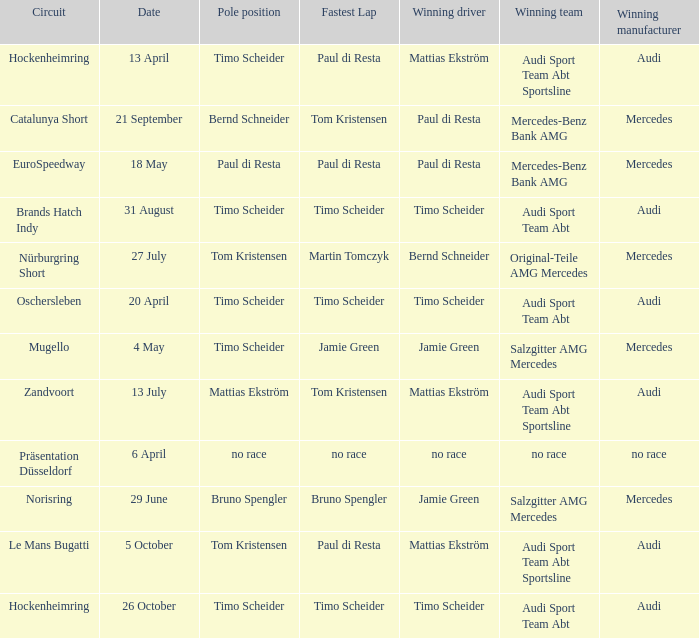What is the fastest lap in the Le Mans Bugatti circuit? Paul di Resta. I'm looking to parse the entire table for insights. Could you assist me with that? {'header': ['Circuit', 'Date', 'Pole position', 'Fastest Lap', 'Winning driver', 'Winning team', 'Winning manufacturer'], 'rows': [['Hockenheimring', '13 April', 'Timo Scheider', 'Paul di Resta', 'Mattias Ekström', 'Audi Sport Team Abt Sportsline', 'Audi'], ['Catalunya Short', '21 September', 'Bernd Schneider', 'Tom Kristensen', 'Paul di Resta', 'Mercedes-Benz Bank AMG', 'Mercedes'], ['EuroSpeedway', '18 May', 'Paul di Resta', 'Paul di Resta', 'Paul di Resta', 'Mercedes-Benz Bank AMG', 'Mercedes'], ['Brands Hatch Indy', '31 August', 'Timo Scheider', 'Timo Scheider', 'Timo Scheider', 'Audi Sport Team Abt', 'Audi'], ['Nürburgring Short', '27 July', 'Tom Kristensen', 'Martin Tomczyk', 'Bernd Schneider', 'Original-Teile AMG Mercedes', 'Mercedes'], ['Oschersleben', '20 April', 'Timo Scheider', 'Timo Scheider', 'Timo Scheider', 'Audi Sport Team Abt', 'Audi'], ['Mugello', '4 May', 'Timo Scheider', 'Jamie Green', 'Jamie Green', 'Salzgitter AMG Mercedes', 'Mercedes'], ['Zandvoort', '13 July', 'Mattias Ekström', 'Tom Kristensen', 'Mattias Ekström', 'Audi Sport Team Abt Sportsline', 'Audi'], ['Präsentation Düsseldorf', '6 April', 'no race', 'no race', 'no race', 'no race', 'no race'], ['Norisring', '29 June', 'Bruno Spengler', 'Bruno Spengler', 'Jamie Green', 'Salzgitter AMG Mercedes', 'Mercedes'], ['Le Mans Bugatti', '5 October', 'Tom Kristensen', 'Paul di Resta', 'Mattias Ekström', 'Audi Sport Team Abt Sportsline', 'Audi'], ['Hockenheimring', '26 October', 'Timo Scheider', 'Timo Scheider', 'Timo Scheider', 'Audi Sport Team Abt', 'Audi']]} 